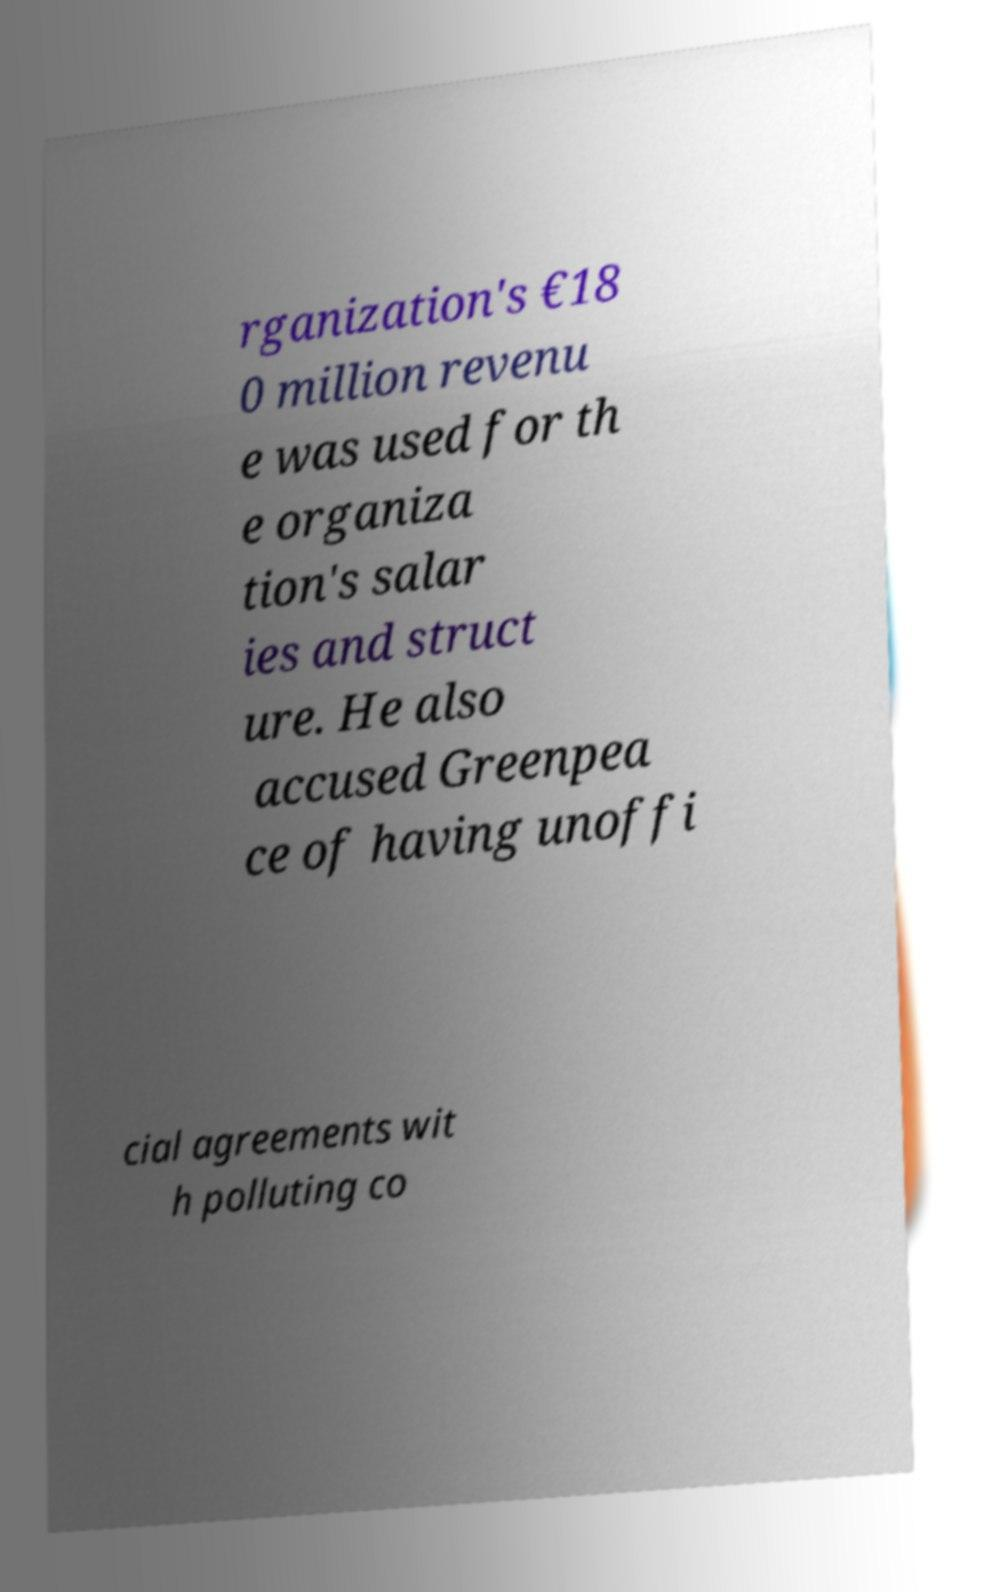Could you extract and type out the text from this image? rganization's €18 0 million revenu e was used for th e organiza tion's salar ies and struct ure. He also accused Greenpea ce of having unoffi cial agreements wit h polluting co 